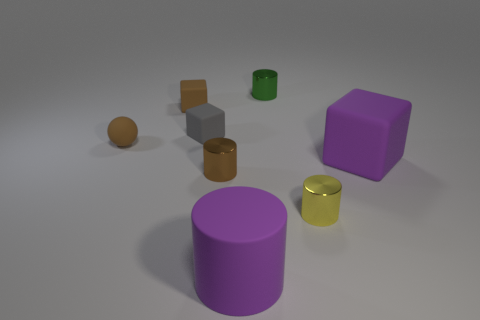Subtract all rubber cylinders. How many cylinders are left? 3 Subtract all green cylinders. How many cylinders are left? 3 Add 1 green matte blocks. How many objects exist? 9 Subtract all spheres. How many objects are left? 7 Subtract all brown cylinders. Subtract all red cubes. How many cylinders are left? 3 Subtract all cyan metal objects. Subtract all green cylinders. How many objects are left? 7 Add 5 small brown balls. How many small brown balls are left? 6 Add 4 cyan shiny cubes. How many cyan shiny cubes exist? 4 Subtract 1 green cylinders. How many objects are left? 7 